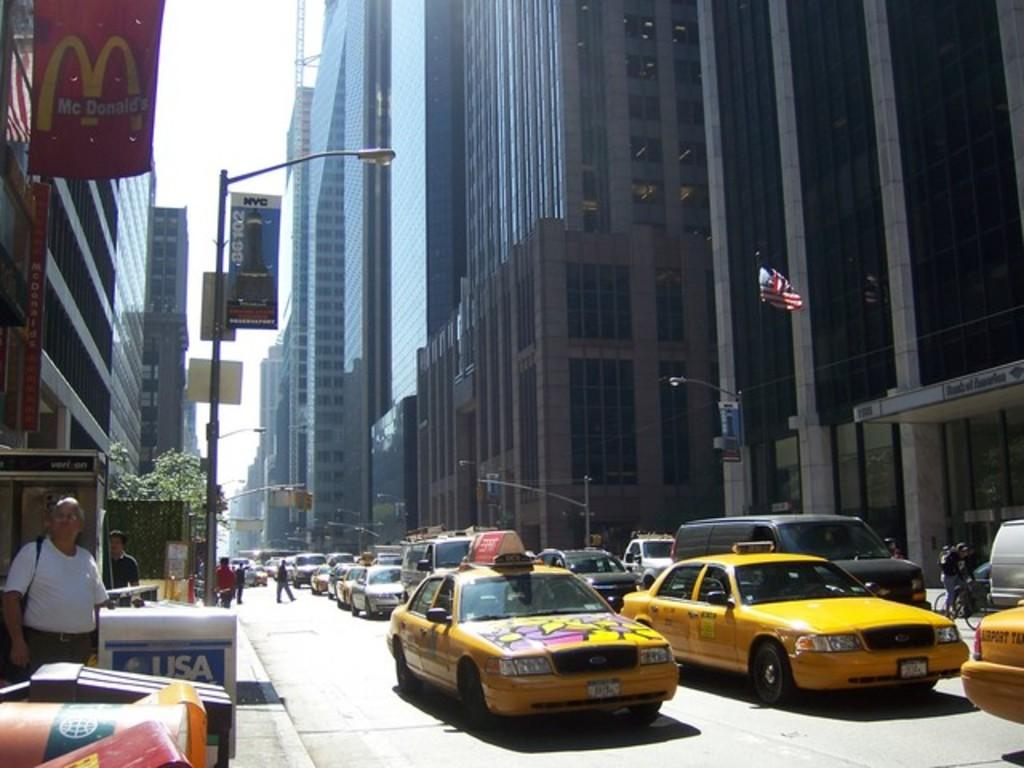<image>
Offer a succinct explanation of the picture presented. A busy city street with a Mcdonalds on the left side. 